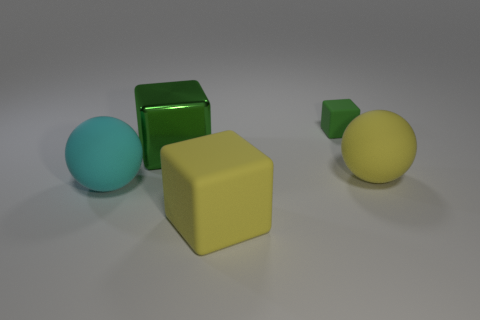Subtract all small green cubes. How many cubes are left? 2 Add 3 big yellow rubber things. How many objects exist? 8 Subtract all cyan balls. How many balls are left? 1 Subtract all cubes. How many objects are left? 2 Subtract all large cyan matte spheres. Subtract all yellow matte things. How many objects are left? 2 Add 1 tiny green rubber things. How many tiny green rubber things are left? 2 Add 2 shiny things. How many shiny things exist? 3 Subtract 1 yellow spheres. How many objects are left? 4 Subtract 1 cubes. How many cubes are left? 2 Subtract all cyan balls. Subtract all brown cylinders. How many balls are left? 1 